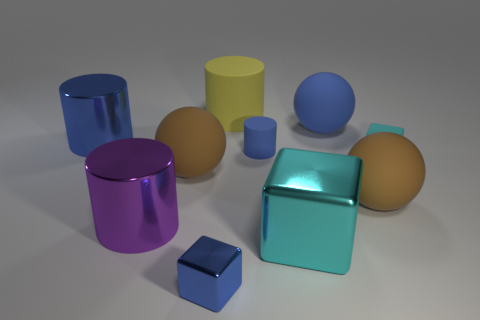Which two objects look like they could contain the most volume? The two objects that stand out as having the potential to contain the most volume are the blue cylinder and the aqua cube due to their larger size compared to the others. 